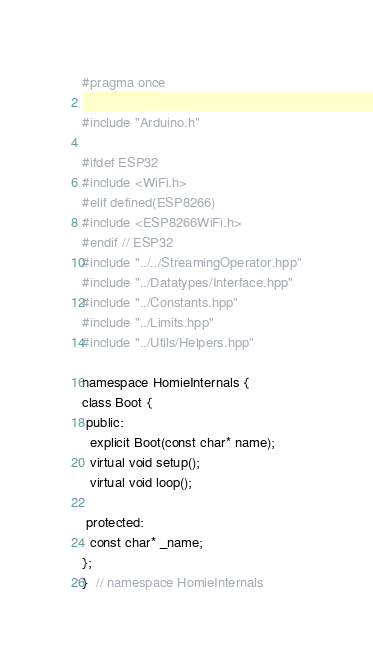Convert code to text. <code><loc_0><loc_0><loc_500><loc_500><_C++_>#pragma once

#include "Arduino.h"

#ifdef ESP32
#include <WiFi.h>
#elif defined(ESP8266)
#include <ESP8266WiFi.h>
#endif // ESP32
#include "../../StreamingOperator.hpp"
#include "../Datatypes/Interface.hpp"
#include "../Constants.hpp"
#include "../Limits.hpp"
#include "../Utils/Helpers.hpp"

namespace HomieInternals {
class Boot {
 public:
  explicit Boot(const char* name);
  virtual void setup();
  virtual void loop();

 protected:
  const char* _name;
};
}  // namespace HomieInternals
</code> 